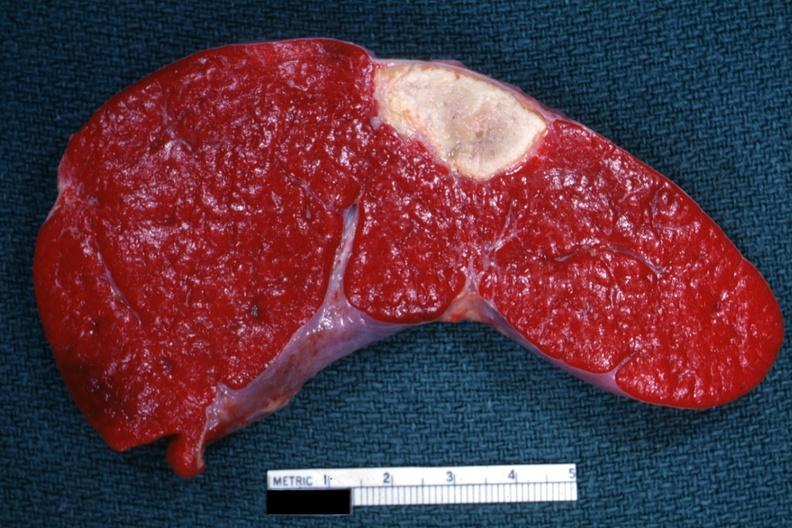does metastatic carcinoma colon show excellent example of old spleen infarct?
Answer the question using a single word or phrase. No 